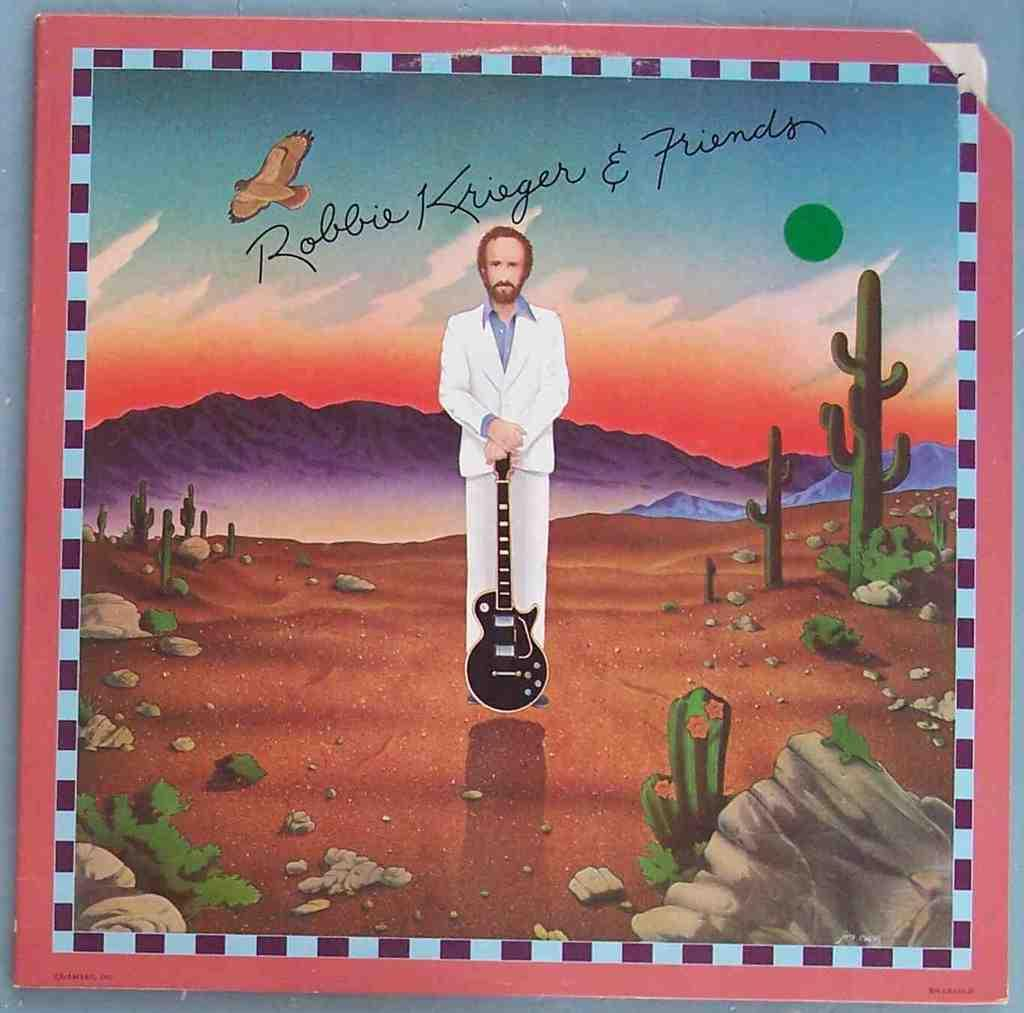<image>
Describe the image concisely. A poster that has a picture of a man holding a guitar in the desert and says Robbie Krieger & Friends. 